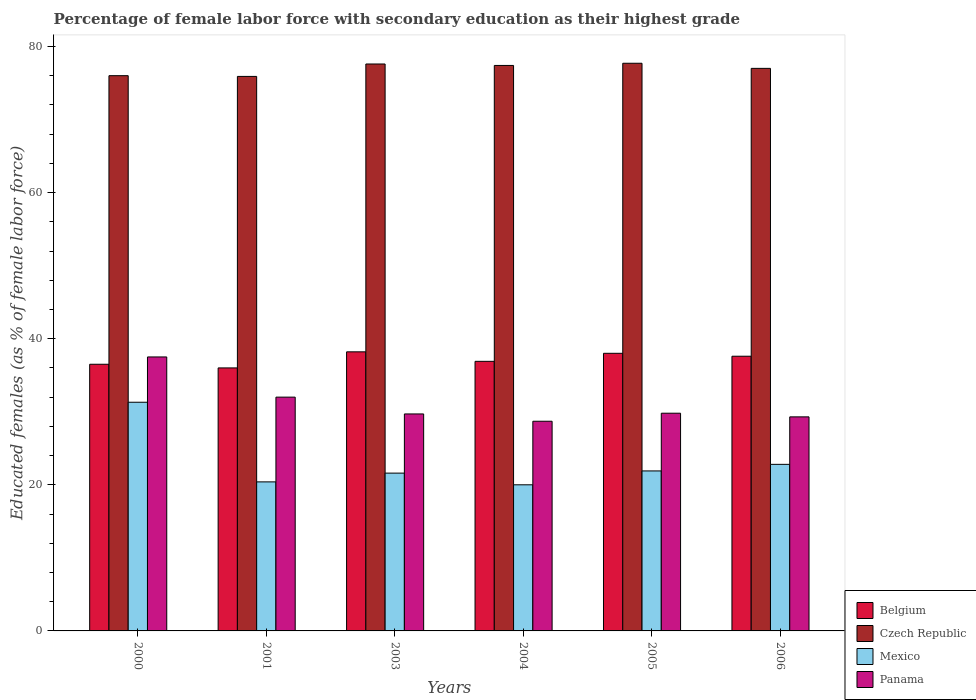How many bars are there on the 6th tick from the right?
Offer a terse response. 4. What is the label of the 4th group of bars from the left?
Make the answer very short. 2004. What is the percentage of female labor force with secondary education in Belgium in 2001?
Your response must be concise. 36. Across all years, what is the maximum percentage of female labor force with secondary education in Czech Republic?
Provide a short and direct response. 77.7. Across all years, what is the minimum percentage of female labor force with secondary education in Belgium?
Ensure brevity in your answer.  36. What is the total percentage of female labor force with secondary education in Czech Republic in the graph?
Provide a succinct answer. 461.6. What is the difference between the percentage of female labor force with secondary education in Panama in 2004 and that in 2006?
Your answer should be compact. -0.6. What is the difference between the percentage of female labor force with secondary education in Mexico in 2003 and the percentage of female labor force with secondary education in Belgium in 2006?
Your answer should be compact. -16. What is the average percentage of female labor force with secondary education in Panama per year?
Make the answer very short. 31.17. In the year 2001, what is the difference between the percentage of female labor force with secondary education in Belgium and percentage of female labor force with secondary education in Mexico?
Provide a succinct answer. 15.6. What is the ratio of the percentage of female labor force with secondary education in Panama in 2000 to that in 2003?
Offer a terse response. 1.26. What is the difference between the highest and the second highest percentage of female labor force with secondary education in Belgium?
Provide a short and direct response. 0.2. What is the difference between the highest and the lowest percentage of female labor force with secondary education in Mexico?
Provide a succinct answer. 11.3. Is it the case that in every year, the sum of the percentage of female labor force with secondary education in Belgium and percentage of female labor force with secondary education in Czech Republic is greater than the sum of percentage of female labor force with secondary education in Mexico and percentage of female labor force with secondary education in Panama?
Provide a succinct answer. Yes. What does the 2nd bar from the left in 2003 represents?
Offer a terse response. Czech Republic. What does the 1st bar from the right in 2005 represents?
Make the answer very short. Panama. How many bars are there?
Your answer should be very brief. 24. Are all the bars in the graph horizontal?
Make the answer very short. No. How many years are there in the graph?
Your response must be concise. 6. Where does the legend appear in the graph?
Make the answer very short. Bottom right. What is the title of the graph?
Offer a terse response. Percentage of female labor force with secondary education as their highest grade. Does "Antigua and Barbuda" appear as one of the legend labels in the graph?
Your answer should be very brief. No. What is the label or title of the X-axis?
Make the answer very short. Years. What is the label or title of the Y-axis?
Provide a short and direct response. Educated females (as % of female labor force). What is the Educated females (as % of female labor force) of Belgium in 2000?
Make the answer very short. 36.5. What is the Educated females (as % of female labor force) of Mexico in 2000?
Your response must be concise. 31.3. What is the Educated females (as % of female labor force) in Panama in 2000?
Offer a terse response. 37.5. What is the Educated females (as % of female labor force) of Czech Republic in 2001?
Keep it short and to the point. 75.9. What is the Educated females (as % of female labor force) of Mexico in 2001?
Provide a short and direct response. 20.4. What is the Educated females (as % of female labor force) in Belgium in 2003?
Keep it short and to the point. 38.2. What is the Educated females (as % of female labor force) in Czech Republic in 2003?
Make the answer very short. 77.6. What is the Educated females (as % of female labor force) of Mexico in 2003?
Provide a succinct answer. 21.6. What is the Educated females (as % of female labor force) of Panama in 2003?
Provide a short and direct response. 29.7. What is the Educated females (as % of female labor force) of Belgium in 2004?
Offer a terse response. 36.9. What is the Educated females (as % of female labor force) in Czech Republic in 2004?
Ensure brevity in your answer.  77.4. What is the Educated females (as % of female labor force) in Mexico in 2004?
Your response must be concise. 20. What is the Educated females (as % of female labor force) of Panama in 2004?
Provide a succinct answer. 28.7. What is the Educated females (as % of female labor force) in Belgium in 2005?
Keep it short and to the point. 38. What is the Educated females (as % of female labor force) in Czech Republic in 2005?
Your response must be concise. 77.7. What is the Educated females (as % of female labor force) in Mexico in 2005?
Make the answer very short. 21.9. What is the Educated females (as % of female labor force) of Panama in 2005?
Your response must be concise. 29.8. What is the Educated females (as % of female labor force) in Belgium in 2006?
Offer a very short reply. 37.6. What is the Educated females (as % of female labor force) in Czech Republic in 2006?
Provide a short and direct response. 77. What is the Educated females (as % of female labor force) of Mexico in 2006?
Your answer should be compact. 22.8. What is the Educated females (as % of female labor force) of Panama in 2006?
Your answer should be compact. 29.3. Across all years, what is the maximum Educated females (as % of female labor force) in Belgium?
Your response must be concise. 38.2. Across all years, what is the maximum Educated females (as % of female labor force) in Czech Republic?
Your answer should be compact. 77.7. Across all years, what is the maximum Educated females (as % of female labor force) in Mexico?
Keep it short and to the point. 31.3. Across all years, what is the maximum Educated females (as % of female labor force) of Panama?
Ensure brevity in your answer.  37.5. Across all years, what is the minimum Educated females (as % of female labor force) in Belgium?
Offer a very short reply. 36. Across all years, what is the minimum Educated females (as % of female labor force) of Czech Republic?
Keep it short and to the point. 75.9. Across all years, what is the minimum Educated females (as % of female labor force) in Panama?
Your answer should be very brief. 28.7. What is the total Educated females (as % of female labor force) in Belgium in the graph?
Your answer should be compact. 223.2. What is the total Educated females (as % of female labor force) of Czech Republic in the graph?
Provide a succinct answer. 461.6. What is the total Educated females (as % of female labor force) in Mexico in the graph?
Keep it short and to the point. 138. What is the total Educated females (as % of female labor force) in Panama in the graph?
Provide a short and direct response. 187. What is the difference between the Educated females (as % of female labor force) of Czech Republic in 2000 and that in 2001?
Provide a succinct answer. 0.1. What is the difference between the Educated females (as % of female labor force) of Belgium in 2000 and that in 2003?
Keep it short and to the point. -1.7. What is the difference between the Educated females (as % of female labor force) in Czech Republic in 2000 and that in 2003?
Ensure brevity in your answer.  -1.6. What is the difference between the Educated females (as % of female labor force) of Panama in 2000 and that in 2004?
Make the answer very short. 8.8. What is the difference between the Educated females (as % of female labor force) in Belgium in 2000 and that in 2005?
Your answer should be compact. -1.5. What is the difference between the Educated females (as % of female labor force) in Czech Republic in 2000 and that in 2005?
Offer a terse response. -1.7. What is the difference between the Educated females (as % of female labor force) of Mexico in 2000 and that in 2005?
Keep it short and to the point. 9.4. What is the difference between the Educated females (as % of female labor force) in Panama in 2000 and that in 2005?
Keep it short and to the point. 7.7. What is the difference between the Educated females (as % of female labor force) in Belgium in 2000 and that in 2006?
Ensure brevity in your answer.  -1.1. What is the difference between the Educated females (as % of female labor force) of Czech Republic in 2000 and that in 2006?
Your answer should be very brief. -1. What is the difference between the Educated females (as % of female labor force) of Panama in 2000 and that in 2006?
Keep it short and to the point. 8.2. What is the difference between the Educated females (as % of female labor force) of Czech Republic in 2001 and that in 2003?
Offer a terse response. -1.7. What is the difference between the Educated females (as % of female labor force) of Panama in 2001 and that in 2003?
Your answer should be very brief. 2.3. What is the difference between the Educated females (as % of female labor force) in Belgium in 2001 and that in 2004?
Provide a short and direct response. -0.9. What is the difference between the Educated females (as % of female labor force) of Mexico in 2001 and that in 2004?
Keep it short and to the point. 0.4. What is the difference between the Educated females (as % of female labor force) of Panama in 2001 and that in 2004?
Your answer should be very brief. 3.3. What is the difference between the Educated females (as % of female labor force) in Belgium in 2001 and that in 2005?
Offer a very short reply. -2. What is the difference between the Educated females (as % of female labor force) in Czech Republic in 2001 and that in 2005?
Offer a terse response. -1.8. What is the difference between the Educated females (as % of female labor force) in Mexico in 2001 and that in 2005?
Your answer should be very brief. -1.5. What is the difference between the Educated females (as % of female labor force) in Czech Republic in 2001 and that in 2006?
Make the answer very short. -1.1. What is the difference between the Educated females (as % of female labor force) in Mexico in 2001 and that in 2006?
Your answer should be compact. -2.4. What is the difference between the Educated females (as % of female labor force) of Panama in 2001 and that in 2006?
Your answer should be very brief. 2.7. What is the difference between the Educated females (as % of female labor force) in Czech Republic in 2003 and that in 2004?
Offer a terse response. 0.2. What is the difference between the Educated females (as % of female labor force) of Mexico in 2003 and that in 2005?
Offer a very short reply. -0.3. What is the difference between the Educated females (as % of female labor force) in Panama in 2003 and that in 2005?
Offer a very short reply. -0.1. What is the difference between the Educated females (as % of female labor force) of Mexico in 2003 and that in 2006?
Your response must be concise. -1.2. What is the difference between the Educated females (as % of female labor force) of Panama in 2004 and that in 2005?
Make the answer very short. -1.1. What is the difference between the Educated females (as % of female labor force) in Belgium in 2004 and that in 2006?
Your answer should be very brief. -0.7. What is the difference between the Educated females (as % of female labor force) of Mexico in 2004 and that in 2006?
Provide a short and direct response. -2.8. What is the difference between the Educated females (as % of female labor force) in Panama in 2004 and that in 2006?
Keep it short and to the point. -0.6. What is the difference between the Educated females (as % of female labor force) of Czech Republic in 2005 and that in 2006?
Provide a short and direct response. 0.7. What is the difference between the Educated females (as % of female labor force) in Belgium in 2000 and the Educated females (as % of female labor force) in Czech Republic in 2001?
Your answer should be very brief. -39.4. What is the difference between the Educated females (as % of female labor force) of Czech Republic in 2000 and the Educated females (as % of female labor force) of Mexico in 2001?
Provide a succinct answer. 55.6. What is the difference between the Educated females (as % of female labor force) of Czech Republic in 2000 and the Educated females (as % of female labor force) of Panama in 2001?
Give a very brief answer. 44. What is the difference between the Educated females (as % of female labor force) of Mexico in 2000 and the Educated females (as % of female labor force) of Panama in 2001?
Your answer should be compact. -0.7. What is the difference between the Educated females (as % of female labor force) in Belgium in 2000 and the Educated females (as % of female labor force) in Czech Republic in 2003?
Your response must be concise. -41.1. What is the difference between the Educated females (as % of female labor force) in Belgium in 2000 and the Educated females (as % of female labor force) in Panama in 2003?
Provide a short and direct response. 6.8. What is the difference between the Educated females (as % of female labor force) in Czech Republic in 2000 and the Educated females (as % of female labor force) in Mexico in 2003?
Ensure brevity in your answer.  54.4. What is the difference between the Educated females (as % of female labor force) in Czech Republic in 2000 and the Educated females (as % of female labor force) in Panama in 2003?
Keep it short and to the point. 46.3. What is the difference between the Educated females (as % of female labor force) of Mexico in 2000 and the Educated females (as % of female labor force) of Panama in 2003?
Offer a very short reply. 1.6. What is the difference between the Educated females (as % of female labor force) in Belgium in 2000 and the Educated females (as % of female labor force) in Czech Republic in 2004?
Your answer should be very brief. -40.9. What is the difference between the Educated females (as % of female labor force) in Belgium in 2000 and the Educated females (as % of female labor force) in Panama in 2004?
Your answer should be compact. 7.8. What is the difference between the Educated females (as % of female labor force) of Czech Republic in 2000 and the Educated females (as % of female labor force) of Mexico in 2004?
Your response must be concise. 56. What is the difference between the Educated females (as % of female labor force) in Czech Republic in 2000 and the Educated females (as % of female labor force) in Panama in 2004?
Provide a succinct answer. 47.3. What is the difference between the Educated females (as % of female labor force) of Mexico in 2000 and the Educated females (as % of female labor force) of Panama in 2004?
Ensure brevity in your answer.  2.6. What is the difference between the Educated females (as % of female labor force) in Belgium in 2000 and the Educated females (as % of female labor force) in Czech Republic in 2005?
Keep it short and to the point. -41.2. What is the difference between the Educated females (as % of female labor force) in Czech Republic in 2000 and the Educated females (as % of female labor force) in Mexico in 2005?
Make the answer very short. 54.1. What is the difference between the Educated females (as % of female labor force) of Czech Republic in 2000 and the Educated females (as % of female labor force) of Panama in 2005?
Offer a very short reply. 46.2. What is the difference between the Educated females (as % of female labor force) of Belgium in 2000 and the Educated females (as % of female labor force) of Czech Republic in 2006?
Make the answer very short. -40.5. What is the difference between the Educated females (as % of female labor force) in Belgium in 2000 and the Educated females (as % of female labor force) in Mexico in 2006?
Ensure brevity in your answer.  13.7. What is the difference between the Educated females (as % of female labor force) in Belgium in 2000 and the Educated females (as % of female labor force) in Panama in 2006?
Offer a very short reply. 7.2. What is the difference between the Educated females (as % of female labor force) of Czech Republic in 2000 and the Educated females (as % of female labor force) of Mexico in 2006?
Ensure brevity in your answer.  53.2. What is the difference between the Educated females (as % of female labor force) of Czech Republic in 2000 and the Educated females (as % of female labor force) of Panama in 2006?
Ensure brevity in your answer.  46.7. What is the difference between the Educated females (as % of female labor force) in Belgium in 2001 and the Educated females (as % of female labor force) in Czech Republic in 2003?
Make the answer very short. -41.6. What is the difference between the Educated females (as % of female labor force) in Belgium in 2001 and the Educated females (as % of female labor force) in Mexico in 2003?
Give a very brief answer. 14.4. What is the difference between the Educated females (as % of female labor force) in Czech Republic in 2001 and the Educated females (as % of female labor force) in Mexico in 2003?
Make the answer very short. 54.3. What is the difference between the Educated females (as % of female labor force) in Czech Republic in 2001 and the Educated females (as % of female labor force) in Panama in 2003?
Offer a very short reply. 46.2. What is the difference between the Educated females (as % of female labor force) in Belgium in 2001 and the Educated females (as % of female labor force) in Czech Republic in 2004?
Ensure brevity in your answer.  -41.4. What is the difference between the Educated females (as % of female labor force) of Belgium in 2001 and the Educated females (as % of female labor force) of Panama in 2004?
Ensure brevity in your answer.  7.3. What is the difference between the Educated females (as % of female labor force) of Czech Republic in 2001 and the Educated females (as % of female labor force) of Mexico in 2004?
Offer a very short reply. 55.9. What is the difference between the Educated females (as % of female labor force) of Czech Republic in 2001 and the Educated females (as % of female labor force) of Panama in 2004?
Offer a terse response. 47.2. What is the difference between the Educated females (as % of female labor force) of Belgium in 2001 and the Educated females (as % of female labor force) of Czech Republic in 2005?
Ensure brevity in your answer.  -41.7. What is the difference between the Educated females (as % of female labor force) in Belgium in 2001 and the Educated females (as % of female labor force) in Panama in 2005?
Provide a short and direct response. 6.2. What is the difference between the Educated females (as % of female labor force) of Czech Republic in 2001 and the Educated females (as % of female labor force) of Mexico in 2005?
Your answer should be compact. 54. What is the difference between the Educated females (as % of female labor force) in Czech Republic in 2001 and the Educated females (as % of female labor force) in Panama in 2005?
Your answer should be very brief. 46.1. What is the difference between the Educated females (as % of female labor force) of Mexico in 2001 and the Educated females (as % of female labor force) of Panama in 2005?
Provide a succinct answer. -9.4. What is the difference between the Educated females (as % of female labor force) in Belgium in 2001 and the Educated females (as % of female labor force) in Czech Republic in 2006?
Provide a succinct answer. -41. What is the difference between the Educated females (as % of female labor force) of Belgium in 2001 and the Educated females (as % of female labor force) of Mexico in 2006?
Provide a short and direct response. 13.2. What is the difference between the Educated females (as % of female labor force) of Belgium in 2001 and the Educated females (as % of female labor force) of Panama in 2006?
Your answer should be very brief. 6.7. What is the difference between the Educated females (as % of female labor force) of Czech Republic in 2001 and the Educated females (as % of female labor force) of Mexico in 2006?
Ensure brevity in your answer.  53.1. What is the difference between the Educated females (as % of female labor force) in Czech Republic in 2001 and the Educated females (as % of female labor force) in Panama in 2006?
Provide a succinct answer. 46.6. What is the difference between the Educated females (as % of female labor force) of Belgium in 2003 and the Educated females (as % of female labor force) of Czech Republic in 2004?
Offer a very short reply. -39.2. What is the difference between the Educated females (as % of female labor force) of Belgium in 2003 and the Educated females (as % of female labor force) of Panama in 2004?
Make the answer very short. 9.5. What is the difference between the Educated females (as % of female labor force) in Czech Republic in 2003 and the Educated females (as % of female labor force) in Mexico in 2004?
Your answer should be very brief. 57.6. What is the difference between the Educated females (as % of female labor force) of Czech Republic in 2003 and the Educated females (as % of female labor force) of Panama in 2004?
Give a very brief answer. 48.9. What is the difference between the Educated females (as % of female labor force) in Mexico in 2003 and the Educated females (as % of female labor force) in Panama in 2004?
Provide a short and direct response. -7.1. What is the difference between the Educated females (as % of female labor force) of Belgium in 2003 and the Educated females (as % of female labor force) of Czech Republic in 2005?
Your response must be concise. -39.5. What is the difference between the Educated females (as % of female labor force) of Czech Republic in 2003 and the Educated females (as % of female labor force) of Mexico in 2005?
Offer a terse response. 55.7. What is the difference between the Educated females (as % of female labor force) in Czech Republic in 2003 and the Educated females (as % of female labor force) in Panama in 2005?
Keep it short and to the point. 47.8. What is the difference between the Educated females (as % of female labor force) of Mexico in 2003 and the Educated females (as % of female labor force) of Panama in 2005?
Offer a very short reply. -8.2. What is the difference between the Educated females (as % of female labor force) of Belgium in 2003 and the Educated females (as % of female labor force) of Czech Republic in 2006?
Give a very brief answer. -38.8. What is the difference between the Educated females (as % of female labor force) in Belgium in 2003 and the Educated females (as % of female labor force) in Mexico in 2006?
Ensure brevity in your answer.  15.4. What is the difference between the Educated females (as % of female labor force) in Czech Republic in 2003 and the Educated females (as % of female labor force) in Mexico in 2006?
Keep it short and to the point. 54.8. What is the difference between the Educated females (as % of female labor force) in Czech Republic in 2003 and the Educated females (as % of female labor force) in Panama in 2006?
Provide a short and direct response. 48.3. What is the difference between the Educated females (as % of female labor force) in Mexico in 2003 and the Educated females (as % of female labor force) in Panama in 2006?
Give a very brief answer. -7.7. What is the difference between the Educated females (as % of female labor force) in Belgium in 2004 and the Educated females (as % of female labor force) in Czech Republic in 2005?
Your response must be concise. -40.8. What is the difference between the Educated females (as % of female labor force) in Belgium in 2004 and the Educated females (as % of female labor force) in Mexico in 2005?
Your answer should be very brief. 15. What is the difference between the Educated females (as % of female labor force) in Belgium in 2004 and the Educated females (as % of female labor force) in Panama in 2005?
Give a very brief answer. 7.1. What is the difference between the Educated females (as % of female labor force) of Czech Republic in 2004 and the Educated females (as % of female labor force) of Mexico in 2005?
Make the answer very short. 55.5. What is the difference between the Educated females (as % of female labor force) of Czech Republic in 2004 and the Educated females (as % of female labor force) of Panama in 2005?
Provide a short and direct response. 47.6. What is the difference between the Educated females (as % of female labor force) in Mexico in 2004 and the Educated females (as % of female labor force) in Panama in 2005?
Your response must be concise. -9.8. What is the difference between the Educated females (as % of female labor force) of Belgium in 2004 and the Educated females (as % of female labor force) of Czech Republic in 2006?
Offer a very short reply. -40.1. What is the difference between the Educated females (as % of female labor force) in Belgium in 2004 and the Educated females (as % of female labor force) in Mexico in 2006?
Your answer should be compact. 14.1. What is the difference between the Educated females (as % of female labor force) in Czech Republic in 2004 and the Educated females (as % of female labor force) in Mexico in 2006?
Keep it short and to the point. 54.6. What is the difference between the Educated females (as % of female labor force) of Czech Republic in 2004 and the Educated females (as % of female labor force) of Panama in 2006?
Offer a terse response. 48.1. What is the difference between the Educated females (as % of female labor force) in Mexico in 2004 and the Educated females (as % of female labor force) in Panama in 2006?
Offer a very short reply. -9.3. What is the difference between the Educated females (as % of female labor force) of Belgium in 2005 and the Educated females (as % of female labor force) of Czech Republic in 2006?
Make the answer very short. -39. What is the difference between the Educated females (as % of female labor force) of Belgium in 2005 and the Educated females (as % of female labor force) of Panama in 2006?
Make the answer very short. 8.7. What is the difference between the Educated females (as % of female labor force) in Czech Republic in 2005 and the Educated females (as % of female labor force) in Mexico in 2006?
Your response must be concise. 54.9. What is the difference between the Educated females (as % of female labor force) of Czech Republic in 2005 and the Educated females (as % of female labor force) of Panama in 2006?
Make the answer very short. 48.4. What is the difference between the Educated females (as % of female labor force) in Mexico in 2005 and the Educated females (as % of female labor force) in Panama in 2006?
Make the answer very short. -7.4. What is the average Educated females (as % of female labor force) of Belgium per year?
Your response must be concise. 37.2. What is the average Educated females (as % of female labor force) in Czech Republic per year?
Your answer should be compact. 76.93. What is the average Educated females (as % of female labor force) of Panama per year?
Keep it short and to the point. 31.17. In the year 2000, what is the difference between the Educated females (as % of female labor force) of Belgium and Educated females (as % of female labor force) of Czech Republic?
Give a very brief answer. -39.5. In the year 2000, what is the difference between the Educated females (as % of female labor force) in Czech Republic and Educated females (as % of female labor force) in Mexico?
Offer a terse response. 44.7. In the year 2000, what is the difference between the Educated females (as % of female labor force) in Czech Republic and Educated females (as % of female labor force) in Panama?
Your answer should be compact. 38.5. In the year 2000, what is the difference between the Educated females (as % of female labor force) of Mexico and Educated females (as % of female labor force) of Panama?
Make the answer very short. -6.2. In the year 2001, what is the difference between the Educated females (as % of female labor force) in Belgium and Educated females (as % of female labor force) in Czech Republic?
Offer a terse response. -39.9. In the year 2001, what is the difference between the Educated females (as % of female labor force) of Belgium and Educated females (as % of female labor force) of Mexico?
Offer a very short reply. 15.6. In the year 2001, what is the difference between the Educated females (as % of female labor force) in Czech Republic and Educated females (as % of female labor force) in Mexico?
Ensure brevity in your answer.  55.5. In the year 2001, what is the difference between the Educated females (as % of female labor force) of Czech Republic and Educated females (as % of female labor force) of Panama?
Your answer should be very brief. 43.9. In the year 2001, what is the difference between the Educated females (as % of female labor force) in Mexico and Educated females (as % of female labor force) in Panama?
Offer a terse response. -11.6. In the year 2003, what is the difference between the Educated females (as % of female labor force) in Belgium and Educated females (as % of female labor force) in Czech Republic?
Offer a very short reply. -39.4. In the year 2003, what is the difference between the Educated females (as % of female labor force) in Belgium and Educated females (as % of female labor force) in Panama?
Offer a terse response. 8.5. In the year 2003, what is the difference between the Educated females (as % of female labor force) in Czech Republic and Educated females (as % of female labor force) in Panama?
Ensure brevity in your answer.  47.9. In the year 2003, what is the difference between the Educated females (as % of female labor force) of Mexico and Educated females (as % of female labor force) of Panama?
Your answer should be compact. -8.1. In the year 2004, what is the difference between the Educated females (as % of female labor force) in Belgium and Educated females (as % of female labor force) in Czech Republic?
Offer a very short reply. -40.5. In the year 2004, what is the difference between the Educated females (as % of female labor force) in Czech Republic and Educated females (as % of female labor force) in Mexico?
Provide a succinct answer. 57.4. In the year 2004, what is the difference between the Educated females (as % of female labor force) in Czech Republic and Educated females (as % of female labor force) in Panama?
Make the answer very short. 48.7. In the year 2004, what is the difference between the Educated females (as % of female labor force) of Mexico and Educated females (as % of female labor force) of Panama?
Your response must be concise. -8.7. In the year 2005, what is the difference between the Educated females (as % of female labor force) of Belgium and Educated females (as % of female labor force) of Czech Republic?
Offer a terse response. -39.7. In the year 2005, what is the difference between the Educated females (as % of female labor force) of Belgium and Educated females (as % of female labor force) of Mexico?
Your answer should be compact. 16.1. In the year 2005, what is the difference between the Educated females (as % of female labor force) of Belgium and Educated females (as % of female labor force) of Panama?
Offer a very short reply. 8.2. In the year 2005, what is the difference between the Educated females (as % of female labor force) of Czech Republic and Educated females (as % of female labor force) of Mexico?
Your answer should be compact. 55.8. In the year 2005, what is the difference between the Educated females (as % of female labor force) in Czech Republic and Educated females (as % of female labor force) in Panama?
Provide a short and direct response. 47.9. In the year 2006, what is the difference between the Educated females (as % of female labor force) in Belgium and Educated females (as % of female labor force) in Czech Republic?
Provide a short and direct response. -39.4. In the year 2006, what is the difference between the Educated females (as % of female labor force) of Belgium and Educated females (as % of female labor force) of Mexico?
Offer a very short reply. 14.8. In the year 2006, what is the difference between the Educated females (as % of female labor force) of Czech Republic and Educated females (as % of female labor force) of Mexico?
Offer a very short reply. 54.2. In the year 2006, what is the difference between the Educated females (as % of female labor force) of Czech Republic and Educated females (as % of female labor force) of Panama?
Provide a short and direct response. 47.7. In the year 2006, what is the difference between the Educated females (as % of female labor force) of Mexico and Educated females (as % of female labor force) of Panama?
Your response must be concise. -6.5. What is the ratio of the Educated females (as % of female labor force) of Belgium in 2000 to that in 2001?
Keep it short and to the point. 1.01. What is the ratio of the Educated females (as % of female labor force) in Mexico in 2000 to that in 2001?
Give a very brief answer. 1.53. What is the ratio of the Educated females (as % of female labor force) in Panama in 2000 to that in 2001?
Your response must be concise. 1.17. What is the ratio of the Educated females (as % of female labor force) of Belgium in 2000 to that in 2003?
Provide a succinct answer. 0.96. What is the ratio of the Educated females (as % of female labor force) in Czech Republic in 2000 to that in 2003?
Ensure brevity in your answer.  0.98. What is the ratio of the Educated females (as % of female labor force) in Mexico in 2000 to that in 2003?
Make the answer very short. 1.45. What is the ratio of the Educated females (as % of female labor force) of Panama in 2000 to that in 2003?
Make the answer very short. 1.26. What is the ratio of the Educated females (as % of female labor force) of Belgium in 2000 to that in 2004?
Your answer should be compact. 0.99. What is the ratio of the Educated females (as % of female labor force) in Czech Republic in 2000 to that in 2004?
Give a very brief answer. 0.98. What is the ratio of the Educated females (as % of female labor force) of Mexico in 2000 to that in 2004?
Ensure brevity in your answer.  1.56. What is the ratio of the Educated females (as % of female labor force) in Panama in 2000 to that in 2004?
Your answer should be compact. 1.31. What is the ratio of the Educated females (as % of female labor force) in Belgium in 2000 to that in 2005?
Your answer should be compact. 0.96. What is the ratio of the Educated females (as % of female labor force) of Czech Republic in 2000 to that in 2005?
Offer a very short reply. 0.98. What is the ratio of the Educated females (as % of female labor force) of Mexico in 2000 to that in 2005?
Offer a terse response. 1.43. What is the ratio of the Educated females (as % of female labor force) of Panama in 2000 to that in 2005?
Provide a succinct answer. 1.26. What is the ratio of the Educated females (as % of female labor force) of Belgium in 2000 to that in 2006?
Give a very brief answer. 0.97. What is the ratio of the Educated females (as % of female labor force) of Czech Republic in 2000 to that in 2006?
Give a very brief answer. 0.99. What is the ratio of the Educated females (as % of female labor force) of Mexico in 2000 to that in 2006?
Provide a succinct answer. 1.37. What is the ratio of the Educated females (as % of female labor force) of Panama in 2000 to that in 2006?
Offer a very short reply. 1.28. What is the ratio of the Educated females (as % of female labor force) in Belgium in 2001 to that in 2003?
Your response must be concise. 0.94. What is the ratio of the Educated females (as % of female labor force) of Czech Republic in 2001 to that in 2003?
Provide a succinct answer. 0.98. What is the ratio of the Educated females (as % of female labor force) of Mexico in 2001 to that in 2003?
Make the answer very short. 0.94. What is the ratio of the Educated females (as % of female labor force) of Panama in 2001 to that in 2003?
Provide a succinct answer. 1.08. What is the ratio of the Educated females (as % of female labor force) in Belgium in 2001 to that in 2004?
Offer a very short reply. 0.98. What is the ratio of the Educated females (as % of female labor force) of Czech Republic in 2001 to that in 2004?
Your response must be concise. 0.98. What is the ratio of the Educated females (as % of female labor force) in Mexico in 2001 to that in 2004?
Your response must be concise. 1.02. What is the ratio of the Educated females (as % of female labor force) in Panama in 2001 to that in 2004?
Provide a succinct answer. 1.11. What is the ratio of the Educated females (as % of female labor force) of Belgium in 2001 to that in 2005?
Your answer should be very brief. 0.95. What is the ratio of the Educated females (as % of female labor force) in Czech Republic in 2001 to that in 2005?
Provide a succinct answer. 0.98. What is the ratio of the Educated females (as % of female labor force) in Mexico in 2001 to that in 2005?
Your answer should be very brief. 0.93. What is the ratio of the Educated females (as % of female labor force) in Panama in 2001 to that in 2005?
Provide a short and direct response. 1.07. What is the ratio of the Educated females (as % of female labor force) of Belgium in 2001 to that in 2006?
Provide a short and direct response. 0.96. What is the ratio of the Educated females (as % of female labor force) of Czech Republic in 2001 to that in 2006?
Keep it short and to the point. 0.99. What is the ratio of the Educated females (as % of female labor force) of Mexico in 2001 to that in 2006?
Make the answer very short. 0.89. What is the ratio of the Educated females (as % of female labor force) of Panama in 2001 to that in 2006?
Offer a very short reply. 1.09. What is the ratio of the Educated females (as % of female labor force) of Belgium in 2003 to that in 2004?
Your answer should be compact. 1.04. What is the ratio of the Educated females (as % of female labor force) in Mexico in 2003 to that in 2004?
Your answer should be very brief. 1.08. What is the ratio of the Educated females (as % of female labor force) of Panama in 2003 to that in 2004?
Keep it short and to the point. 1.03. What is the ratio of the Educated females (as % of female labor force) of Belgium in 2003 to that in 2005?
Your answer should be compact. 1.01. What is the ratio of the Educated females (as % of female labor force) of Czech Republic in 2003 to that in 2005?
Provide a short and direct response. 1. What is the ratio of the Educated females (as % of female labor force) in Mexico in 2003 to that in 2005?
Provide a succinct answer. 0.99. What is the ratio of the Educated females (as % of female labor force) of Belgium in 2003 to that in 2006?
Keep it short and to the point. 1.02. What is the ratio of the Educated females (as % of female labor force) of Czech Republic in 2003 to that in 2006?
Provide a succinct answer. 1.01. What is the ratio of the Educated females (as % of female labor force) of Panama in 2003 to that in 2006?
Offer a terse response. 1.01. What is the ratio of the Educated females (as % of female labor force) in Belgium in 2004 to that in 2005?
Keep it short and to the point. 0.97. What is the ratio of the Educated females (as % of female labor force) of Czech Republic in 2004 to that in 2005?
Offer a terse response. 1. What is the ratio of the Educated females (as % of female labor force) in Mexico in 2004 to that in 2005?
Your response must be concise. 0.91. What is the ratio of the Educated females (as % of female labor force) of Panama in 2004 to that in 2005?
Provide a short and direct response. 0.96. What is the ratio of the Educated females (as % of female labor force) of Belgium in 2004 to that in 2006?
Offer a very short reply. 0.98. What is the ratio of the Educated females (as % of female labor force) of Czech Republic in 2004 to that in 2006?
Provide a succinct answer. 1.01. What is the ratio of the Educated females (as % of female labor force) in Mexico in 2004 to that in 2006?
Make the answer very short. 0.88. What is the ratio of the Educated females (as % of female labor force) of Panama in 2004 to that in 2006?
Make the answer very short. 0.98. What is the ratio of the Educated females (as % of female labor force) in Belgium in 2005 to that in 2006?
Offer a terse response. 1.01. What is the ratio of the Educated females (as % of female labor force) in Czech Republic in 2005 to that in 2006?
Ensure brevity in your answer.  1.01. What is the ratio of the Educated females (as % of female labor force) of Mexico in 2005 to that in 2006?
Give a very brief answer. 0.96. What is the ratio of the Educated females (as % of female labor force) in Panama in 2005 to that in 2006?
Your answer should be compact. 1.02. What is the difference between the highest and the second highest Educated females (as % of female labor force) of Czech Republic?
Offer a very short reply. 0.1. What is the difference between the highest and the second highest Educated females (as % of female labor force) in Mexico?
Your answer should be compact. 8.5. What is the difference between the highest and the lowest Educated females (as % of female labor force) in Mexico?
Make the answer very short. 11.3. What is the difference between the highest and the lowest Educated females (as % of female labor force) of Panama?
Offer a very short reply. 8.8. 